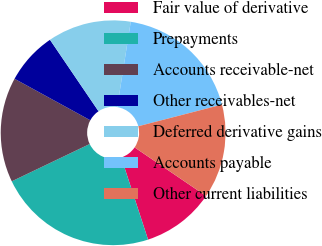Convert chart to OTSL. <chart><loc_0><loc_0><loc_500><loc_500><pie_chart><fcel>Fair value of derivative<fcel>Prepayments<fcel>Accounts receivable-net<fcel>Other receivables-net<fcel>Deferred derivative gains<fcel>Accounts payable<fcel>Other current liabilities<nl><fcel>10.46%<fcel>22.92%<fcel>15.08%<fcel>7.53%<fcel>12.0%<fcel>18.46%<fcel>13.54%<nl></chart> 